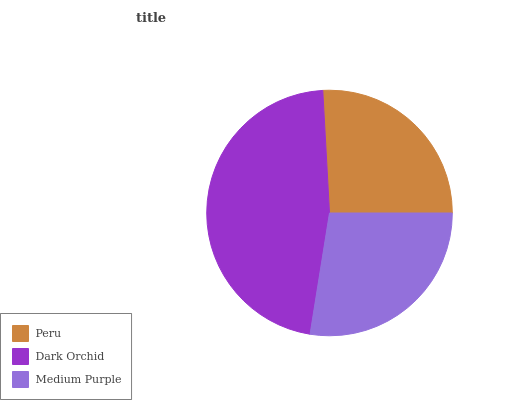Is Peru the minimum?
Answer yes or no. Yes. Is Dark Orchid the maximum?
Answer yes or no. Yes. Is Medium Purple the minimum?
Answer yes or no. No. Is Medium Purple the maximum?
Answer yes or no. No. Is Dark Orchid greater than Medium Purple?
Answer yes or no. Yes. Is Medium Purple less than Dark Orchid?
Answer yes or no. Yes. Is Medium Purple greater than Dark Orchid?
Answer yes or no. No. Is Dark Orchid less than Medium Purple?
Answer yes or no. No. Is Medium Purple the high median?
Answer yes or no. Yes. Is Medium Purple the low median?
Answer yes or no. Yes. Is Dark Orchid the high median?
Answer yes or no. No. Is Dark Orchid the low median?
Answer yes or no. No. 